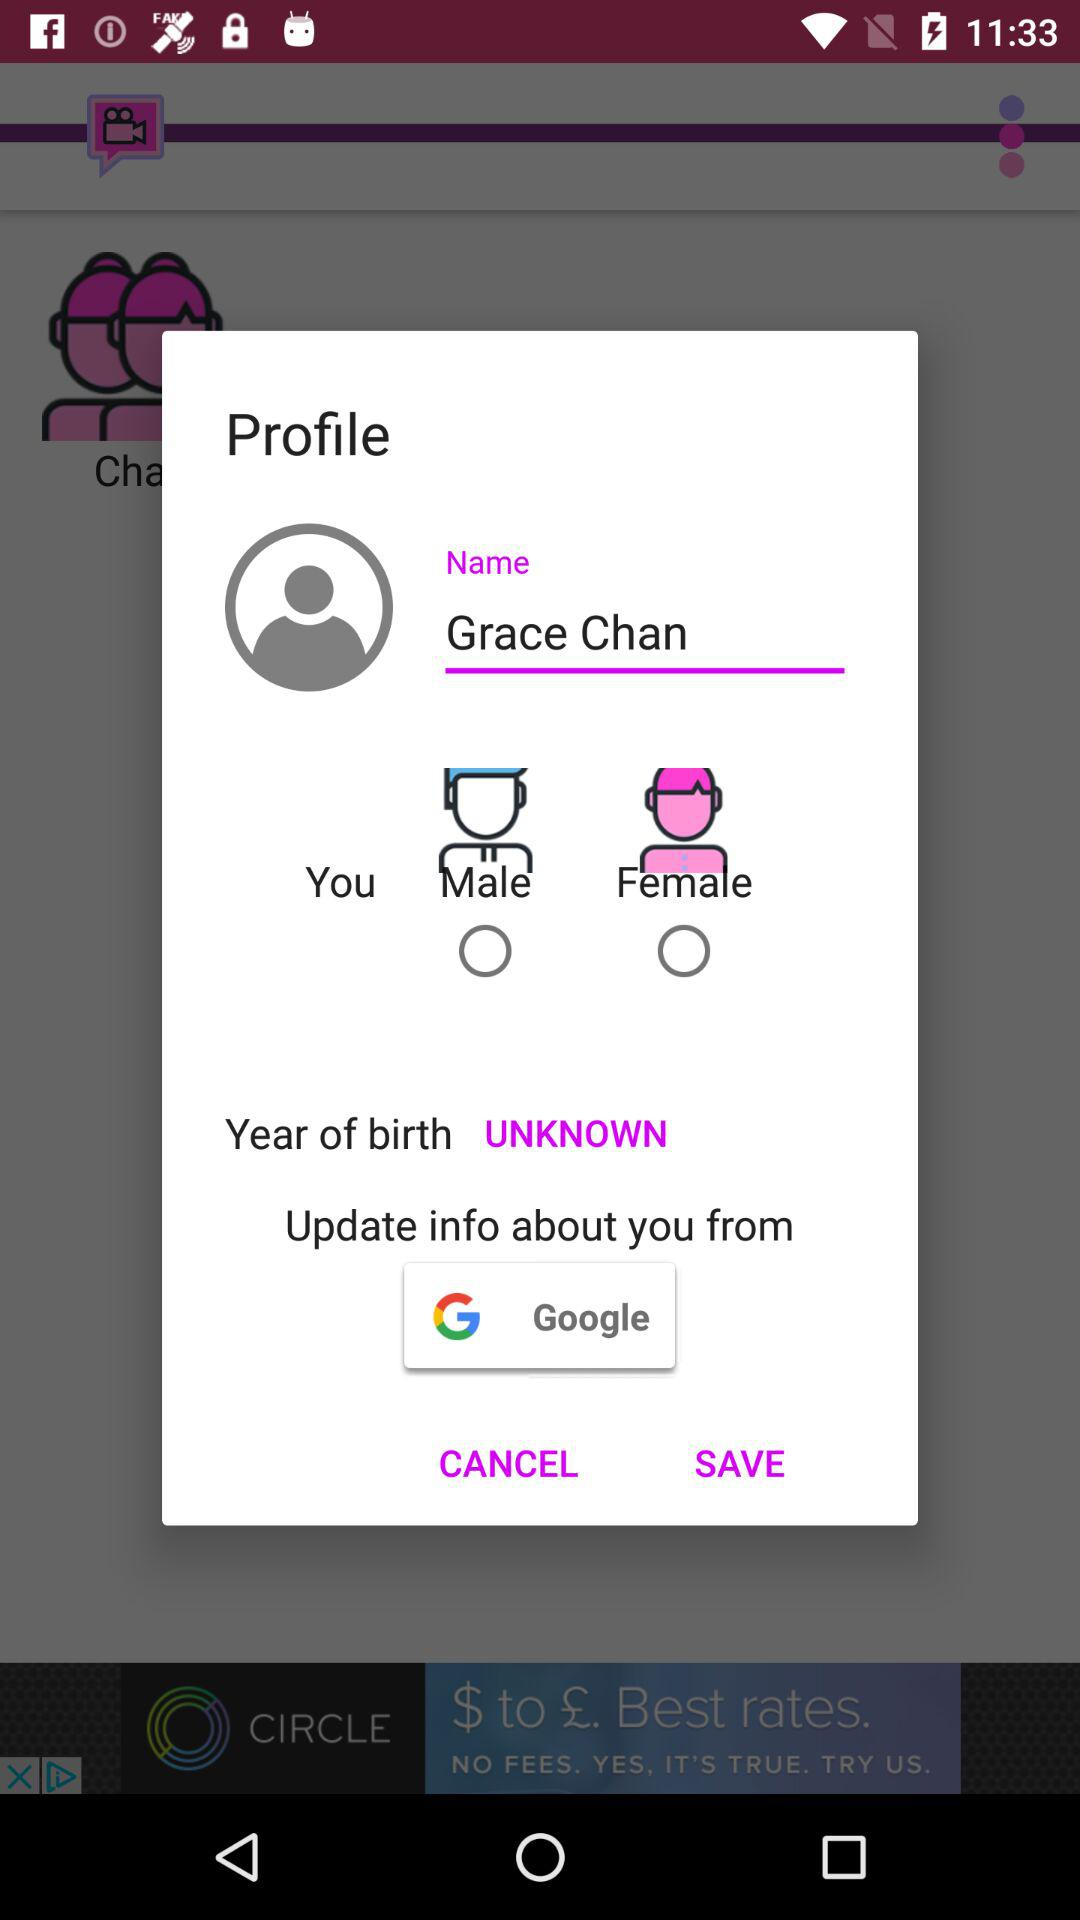From where can we update the information? You can update the information from "Google". 